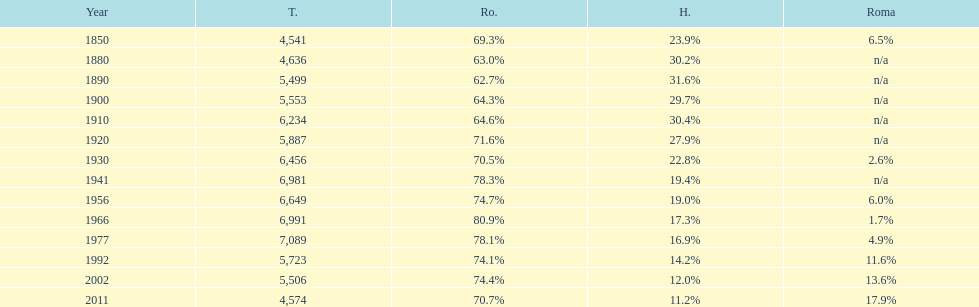In the last year displayed on this chart, what fraction of the population was made up of romanians? 70.7%. 